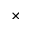Convert formula to latex. <formula><loc_0><loc_0><loc_500><loc_500>\times</formula> 